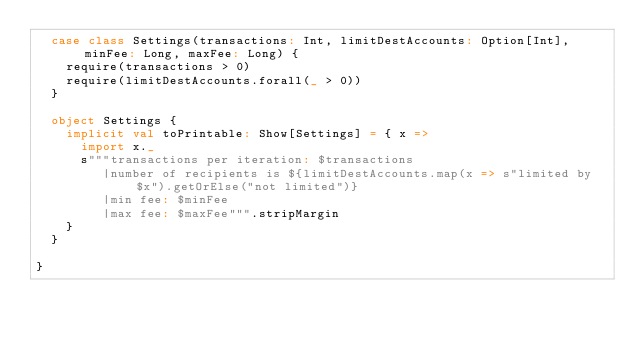<code> <loc_0><loc_0><loc_500><loc_500><_Scala_>  case class Settings(transactions: Int, limitDestAccounts: Option[Int], minFee: Long, maxFee: Long) {
    require(transactions > 0)
    require(limitDestAccounts.forall(_ > 0))
  }

  object Settings {
    implicit val toPrintable: Show[Settings] = { x =>
      import x._
      s"""transactions per iteration: $transactions
         |number of recipients is ${limitDestAccounts.map(x => s"limited by $x").getOrElse("not limited")}
         |min fee: $minFee
         |max fee: $maxFee""".stripMargin
    }
  }

}
</code> 